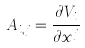<formula> <loc_0><loc_0><loc_500><loc_500>A _ { i , j } = \frac { \partial V _ { i } } { \partial x ^ { j } }</formula> 